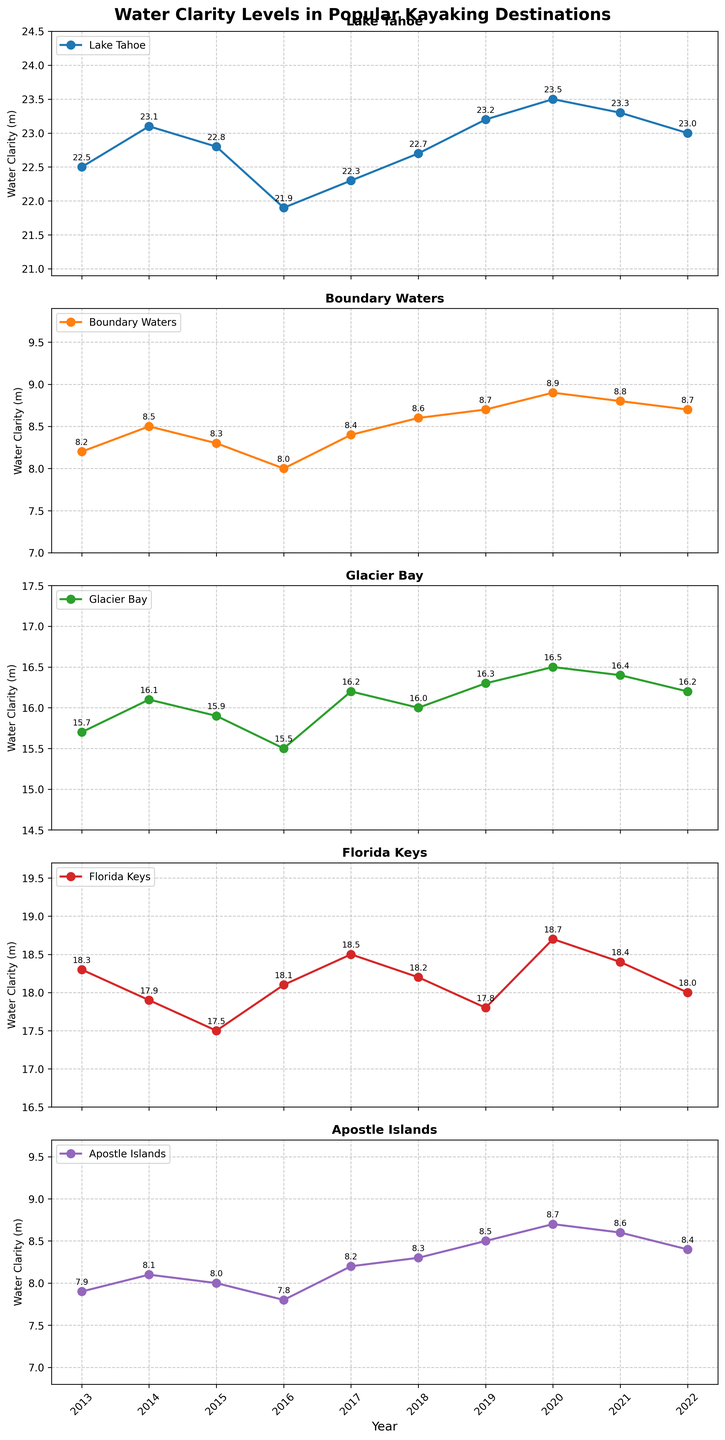Which location has the highest water clarity in the year 2018? To find which location has the highest water clarity in 2018, look at the values in the subplot labeled "2018." The highest value is for "Lake Tahoe" with 22.7 meters.
Answer: Lake Tahoe Which location consistently has the lowest water clarity over the decade? Evaluate all the subplots and compare the water clarity values. The "Boundary Waters" have consistently lower values throughout the years compared to other locations.
Answer: Boundary Waters How does the water clarity of Apostle Islands change from 2013 to 2022? To determine the change, subtract the 2013 value from the 2022 value. For Apostle Islands, the water clarity in 2013 is 7.9 meters, and in 2022 it is 8.4 meters. Therefore, the change is 8.4 - 7.9 = 0.5 meters.
Answer: Increases by 0.5 meters Compare the water clarity trend of Glacier Bay and Florida Keys from 2018 to 2020. Which one shows a greater increase? Check the values from 2018 to 2020 for both locations. Glacier Bay increases from 16.0 to 16.5, a difference of 0.5 meters. Florida Keys increases from 18.2 to 18.7, a difference of 0.5 meters. Both show the same increase.
Answer: Both show the same increase What is the average water clarity in Lake Tahoe over the decade? To find the average, add up the annual values for Lake Tahoe from 2013 to 2022 and divide by the number of years. The sum is 226.3 meters, and there are 10 years, so the average is 226.3 / 10 = 22.63 meters.
Answer: 22.63 meters In which year did the Boundary Waters experience the highest water clarity? Look at the subplot for Boundary Waters and identify the highest value. The highest water clarity is 8.9 meters in 2020.
Answer: 2020 Between 2015 and 2019, which location had the most stable water clarity values? Compare the values for each location between 2015 and 2019. Boundary Waters have values ranging from 8.0 to 8.7, which shows less fluctuation compared to other locations.
Answer: Boundary Waters Visualize the trends: Which location shows an overall upward trend of water clarity from 2013 to 2022? Visually examine each subplot for the overall direction of the trend. For Lake Tahoe, the values generally increase from 22.5 meters in 2013 to 23.0 meters in 2022. Other locations show more fluctuation.
Answer: Lake Tahoe In 2021, which location had the closest water clarity values to Glacier Bay? Compare the 2021 clarity values. Glacier Bay has 16.4 meters, and the closest values are "Florida Keys" with 18.4 meters.
Answer: Florida Keys What is the difference in water clarity between the Florida Keys and Boundary Waters in 2019? To find the difference, subtract the 2019 value of Boundary Waters from the 2019 value of Florida Keys. Florida Keys has 17.8 meters, and Boundary Waters has 8.7 meters. Therefore, the difference is 17.8 - 8.7 = 9.1 meters.
Answer: 9.1 meters 